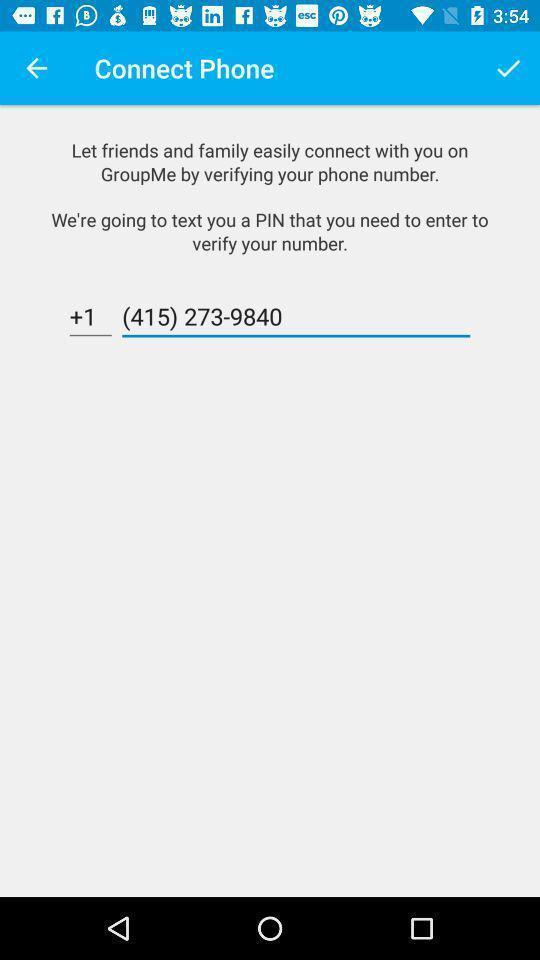Summarize the information in this screenshot. Page showing phone number option. 